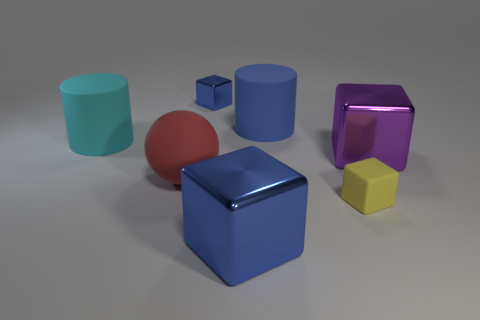Can you compare the sizes of the objects? Certainly! Focusing on size, the teal cylinder is the tallest object, albeit with a smaller diameter than some of the cubes. The large blue cube is quite bulky with significant volume. The red sphere and purple cube are roughly intermediate in size, while the yellow hexagonal prism is slightly smaller. Finally, the small blue cube is the tiniest object visible, easily distinguishable from the others by its significantly smaller dimensions. 